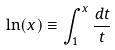<formula> <loc_0><loc_0><loc_500><loc_500>\ln ( x ) \equiv \int _ { 1 } ^ { x } \frac { d t } { t }</formula> 